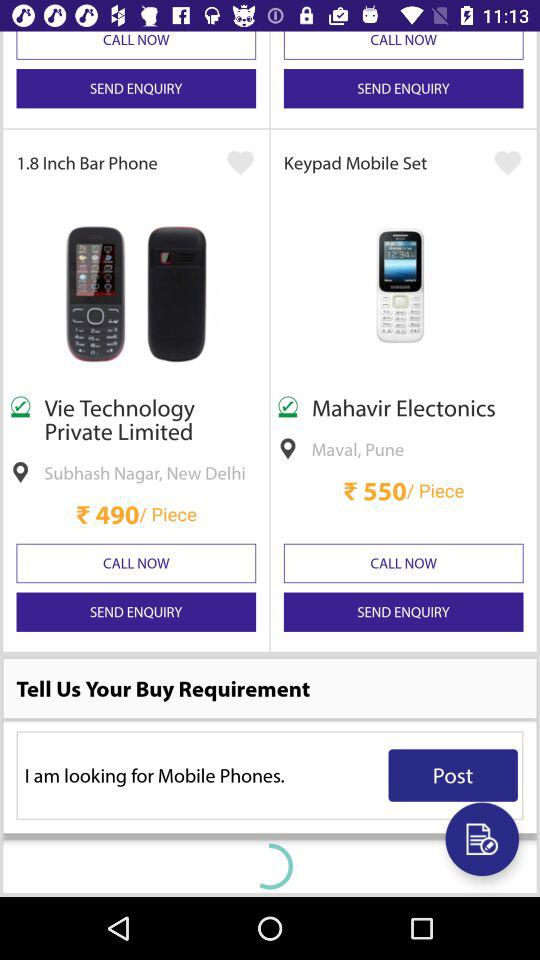How many items have a location specified?
Answer the question using a single word or phrase. 2 